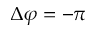Convert formula to latex. <formula><loc_0><loc_0><loc_500><loc_500>\Delta \varphi = - \pi</formula> 